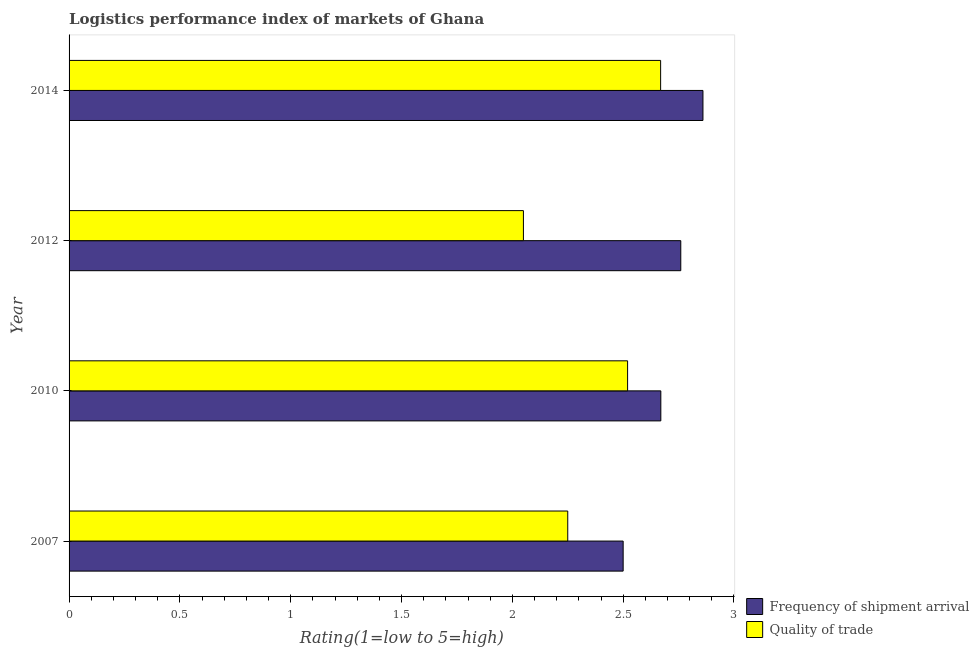How many different coloured bars are there?
Provide a succinct answer. 2. How many groups of bars are there?
Your response must be concise. 4. How many bars are there on the 4th tick from the bottom?
Provide a short and direct response. 2. In how many cases, is the number of bars for a given year not equal to the number of legend labels?
Your answer should be compact. 0. What is the lpi of frequency of shipment arrival in 2010?
Offer a very short reply. 2.67. Across all years, what is the maximum lpi quality of trade?
Keep it short and to the point. 2.67. Across all years, what is the minimum lpi quality of trade?
Offer a terse response. 2.05. In which year was the lpi of frequency of shipment arrival maximum?
Provide a short and direct response. 2014. What is the total lpi of frequency of shipment arrival in the graph?
Provide a succinct answer. 10.79. What is the difference between the lpi of frequency of shipment arrival in 2010 and that in 2012?
Provide a succinct answer. -0.09. What is the difference between the lpi of frequency of shipment arrival in 2012 and the lpi quality of trade in 2007?
Give a very brief answer. 0.51. What is the average lpi quality of trade per year?
Make the answer very short. 2.37. In how many years, is the lpi of frequency of shipment arrival greater than 0.7 ?
Ensure brevity in your answer.  4. What is the ratio of the lpi quality of trade in 2007 to that in 2014?
Your response must be concise. 0.84. Is the difference between the lpi quality of trade in 2010 and 2012 greater than the difference between the lpi of frequency of shipment arrival in 2010 and 2012?
Offer a very short reply. Yes. What is the difference between the highest and the second highest lpi quality of trade?
Offer a terse response. 0.15. What is the difference between the highest and the lowest lpi quality of trade?
Ensure brevity in your answer.  0.62. Is the sum of the lpi quality of trade in 2007 and 2012 greater than the maximum lpi of frequency of shipment arrival across all years?
Keep it short and to the point. Yes. What does the 2nd bar from the top in 2010 represents?
Provide a succinct answer. Frequency of shipment arrival. What does the 1st bar from the bottom in 2010 represents?
Ensure brevity in your answer.  Frequency of shipment arrival. How many bars are there?
Ensure brevity in your answer.  8. Are all the bars in the graph horizontal?
Your answer should be very brief. Yes. How many years are there in the graph?
Ensure brevity in your answer.  4. What is the difference between two consecutive major ticks on the X-axis?
Your answer should be very brief. 0.5. Does the graph contain any zero values?
Provide a short and direct response. No. Where does the legend appear in the graph?
Your answer should be very brief. Bottom right. How many legend labels are there?
Keep it short and to the point. 2. What is the title of the graph?
Give a very brief answer. Logistics performance index of markets of Ghana. Does "Personal remittances" appear as one of the legend labels in the graph?
Your answer should be compact. No. What is the label or title of the X-axis?
Provide a short and direct response. Rating(1=low to 5=high). What is the label or title of the Y-axis?
Your answer should be compact. Year. What is the Rating(1=low to 5=high) of Frequency of shipment arrival in 2007?
Offer a terse response. 2.5. What is the Rating(1=low to 5=high) of Quality of trade in 2007?
Keep it short and to the point. 2.25. What is the Rating(1=low to 5=high) of Frequency of shipment arrival in 2010?
Provide a short and direct response. 2.67. What is the Rating(1=low to 5=high) in Quality of trade in 2010?
Offer a very short reply. 2.52. What is the Rating(1=low to 5=high) in Frequency of shipment arrival in 2012?
Your answer should be very brief. 2.76. What is the Rating(1=low to 5=high) in Quality of trade in 2012?
Provide a succinct answer. 2.05. What is the Rating(1=low to 5=high) in Frequency of shipment arrival in 2014?
Keep it short and to the point. 2.86. What is the Rating(1=low to 5=high) in Quality of trade in 2014?
Your response must be concise. 2.67. Across all years, what is the maximum Rating(1=low to 5=high) in Frequency of shipment arrival?
Ensure brevity in your answer.  2.86. Across all years, what is the maximum Rating(1=low to 5=high) of Quality of trade?
Offer a terse response. 2.67. Across all years, what is the minimum Rating(1=low to 5=high) in Frequency of shipment arrival?
Give a very brief answer. 2.5. Across all years, what is the minimum Rating(1=low to 5=high) in Quality of trade?
Give a very brief answer. 2.05. What is the total Rating(1=low to 5=high) in Frequency of shipment arrival in the graph?
Offer a terse response. 10.79. What is the total Rating(1=low to 5=high) of Quality of trade in the graph?
Ensure brevity in your answer.  9.49. What is the difference between the Rating(1=low to 5=high) in Frequency of shipment arrival in 2007 and that in 2010?
Offer a very short reply. -0.17. What is the difference between the Rating(1=low to 5=high) in Quality of trade in 2007 and that in 2010?
Provide a short and direct response. -0.27. What is the difference between the Rating(1=low to 5=high) in Frequency of shipment arrival in 2007 and that in 2012?
Give a very brief answer. -0.26. What is the difference between the Rating(1=low to 5=high) in Quality of trade in 2007 and that in 2012?
Keep it short and to the point. 0.2. What is the difference between the Rating(1=low to 5=high) of Frequency of shipment arrival in 2007 and that in 2014?
Provide a short and direct response. -0.36. What is the difference between the Rating(1=low to 5=high) of Quality of trade in 2007 and that in 2014?
Make the answer very short. -0.42. What is the difference between the Rating(1=low to 5=high) in Frequency of shipment arrival in 2010 and that in 2012?
Your answer should be very brief. -0.09. What is the difference between the Rating(1=low to 5=high) in Quality of trade in 2010 and that in 2012?
Make the answer very short. 0.47. What is the difference between the Rating(1=low to 5=high) in Frequency of shipment arrival in 2010 and that in 2014?
Offer a very short reply. -0.19. What is the difference between the Rating(1=low to 5=high) of Quality of trade in 2010 and that in 2014?
Ensure brevity in your answer.  -0.15. What is the difference between the Rating(1=low to 5=high) in Quality of trade in 2012 and that in 2014?
Your response must be concise. -0.62. What is the difference between the Rating(1=low to 5=high) of Frequency of shipment arrival in 2007 and the Rating(1=low to 5=high) of Quality of trade in 2010?
Provide a short and direct response. -0.02. What is the difference between the Rating(1=low to 5=high) in Frequency of shipment arrival in 2007 and the Rating(1=low to 5=high) in Quality of trade in 2012?
Provide a short and direct response. 0.45. What is the difference between the Rating(1=low to 5=high) of Frequency of shipment arrival in 2007 and the Rating(1=low to 5=high) of Quality of trade in 2014?
Provide a short and direct response. -0.17. What is the difference between the Rating(1=low to 5=high) of Frequency of shipment arrival in 2010 and the Rating(1=low to 5=high) of Quality of trade in 2012?
Your response must be concise. 0.62. What is the difference between the Rating(1=low to 5=high) of Frequency of shipment arrival in 2010 and the Rating(1=low to 5=high) of Quality of trade in 2014?
Provide a short and direct response. 0. What is the difference between the Rating(1=low to 5=high) in Frequency of shipment arrival in 2012 and the Rating(1=low to 5=high) in Quality of trade in 2014?
Make the answer very short. 0.09. What is the average Rating(1=low to 5=high) in Frequency of shipment arrival per year?
Your response must be concise. 2.7. What is the average Rating(1=low to 5=high) of Quality of trade per year?
Your response must be concise. 2.37. In the year 2012, what is the difference between the Rating(1=low to 5=high) of Frequency of shipment arrival and Rating(1=low to 5=high) of Quality of trade?
Your answer should be compact. 0.71. In the year 2014, what is the difference between the Rating(1=low to 5=high) in Frequency of shipment arrival and Rating(1=low to 5=high) in Quality of trade?
Make the answer very short. 0.19. What is the ratio of the Rating(1=low to 5=high) of Frequency of shipment arrival in 2007 to that in 2010?
Your answer should be very brief. 0.94. What is the ratio of the Rating(1=low to 5=high) of Quality of trade in 2007 to that in 2010?
Your response must be concise. 0.89. What is the ratio of the Rating(1=low to 5=high) of Frequency of shipment arrival in 2007 to that in 2012?
Ensure brevity in your answer.  0.91. What is the ratio of the Rating(1=low to 5=high) in Quality of trade in 2007 to that in 2012?
Your answer should be compact. 1.1. What is the ratio of the Rating(1=low to 5=high) in Frequency of shipment arrival in 2007 to that in 2014?
Ensure brevity in your answer.  0.87. What is the ratio of the Rating(1=low to 5=high) in Quality of trade in 2007 to that in 2014?
Your response must be concise. 0.84. What is the ratio of the Rating(1=low to 5=high) in Frequency of shipment arrival in 2010 to that in 2012?
Your answer should be very brief. 0.97. What is the ratio of the Rating(1=low to 5=high) in Quality of trade in 2010 to that in 2012?
Your answer should be compact. 1.23. What is the ratio of the Rating(1=low to 5=high) of Frequency of shipment arrival in 2010 to that in 2014?
Keep it short and to the point. 0.93. What is the ratio of the Rating(1=low to 5=high) in Quality of trade in 2010 to that in 2014?
Your answer should be very brief. 0.94. What is the ratio of the Rating(1=low to 5=high) in Frequency of shipment arrival in 2012 to that in 2014?
Offer a very short reply. 0.96. What is the ratio of the Rating(1=low to 5=high) in Quality of trade in 2012 to that in 2014?
Ensure brevity in your answer.  0.77. What is the difference between the highest and the second highest Rating(1=low to 5=high) in Frequency of shipment arrival?
Make the answer very short. 0.1. What is the difference between the highest and the second highest Rating(1=low to 5=high) of Quality of trade?
Ensure brevity in your answer.  0.15. What is the difference between the highest and the lowest Rating(1=low to 5=high) of Frequency of shipment arrival?
Provide a short and direct response. 0.36. What is the difference between the highest and the lowest Rating(1=low to 5=high) of Quality of trade?
Your response must be concise. 0.62. 